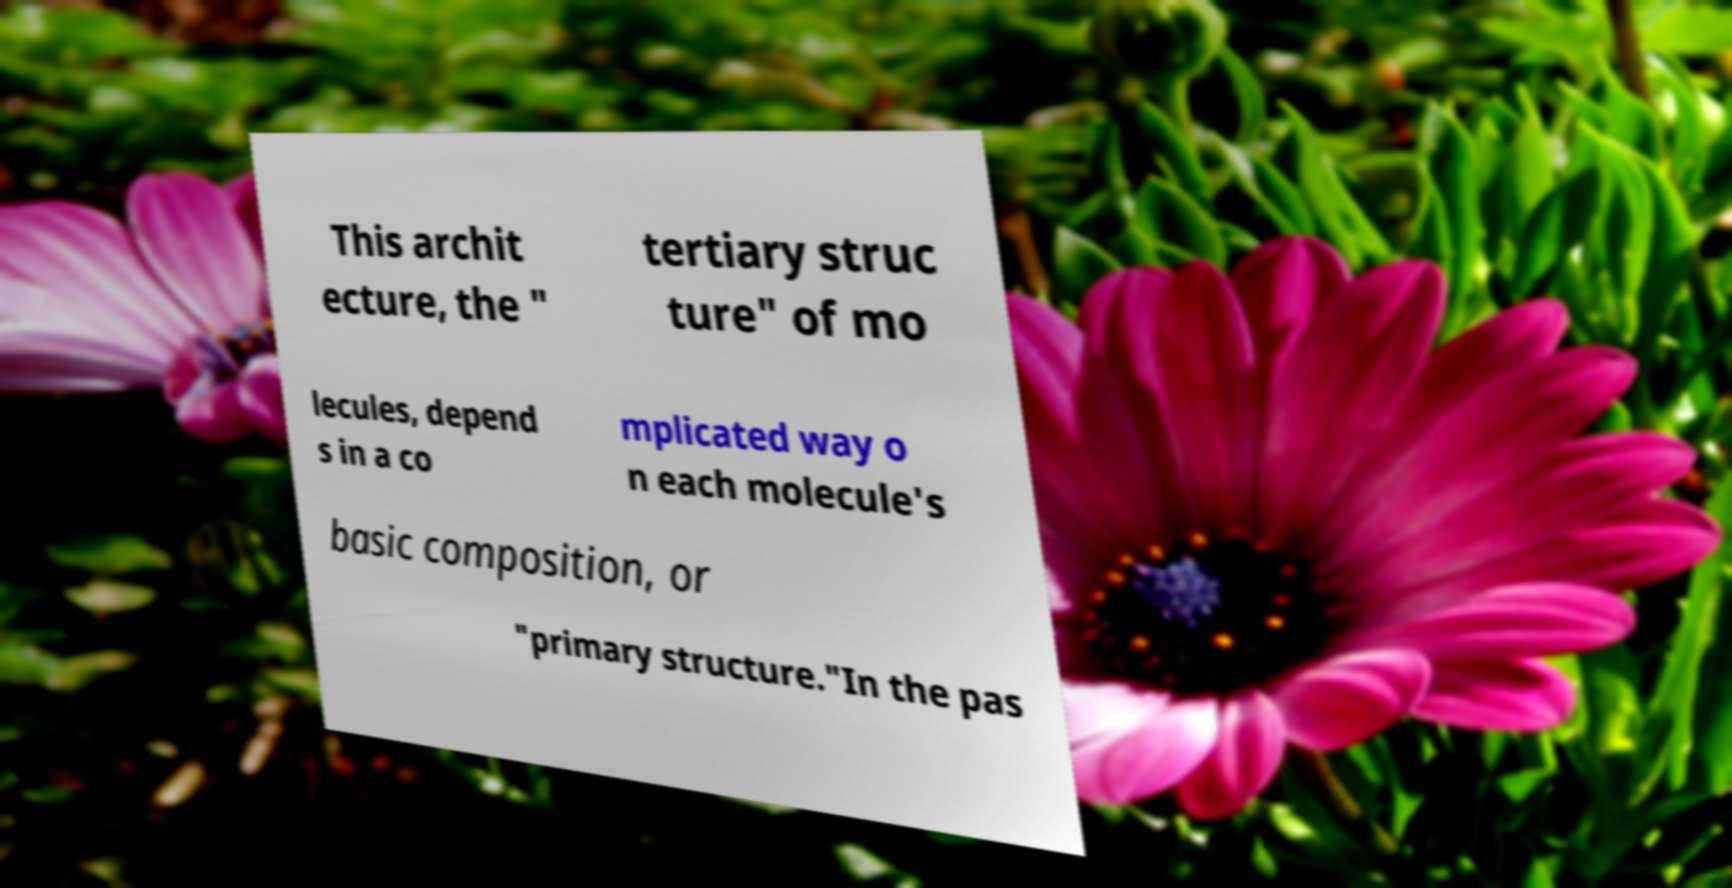Could you assist in decoding the text presented in this image and type it out clearly? This archit ecture, the " tertiary struc ture" of mo lecules, depend s in a co mplicated way o n each molecule's basic composition, or "primary structure."In the pas 